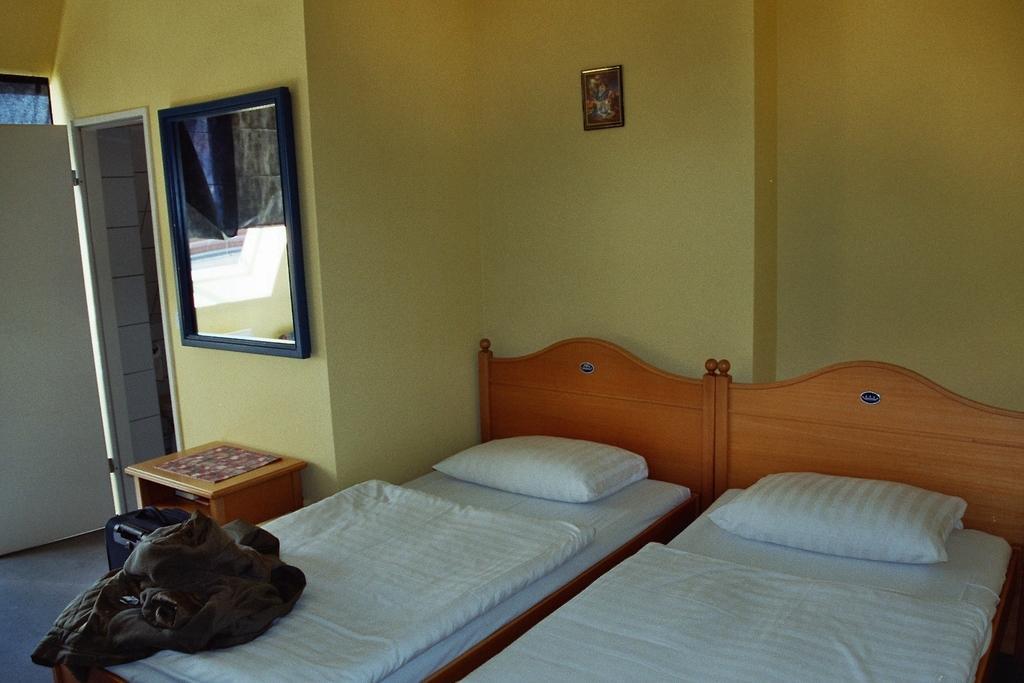Describe this image in one or two sentences. In this image, we can see a mirror, photo frame, door, wall. At the bottom, we can see beds with mattresses, bed sheets and pillows. Here we can see some cloth, luggage bag, desk few objects. 